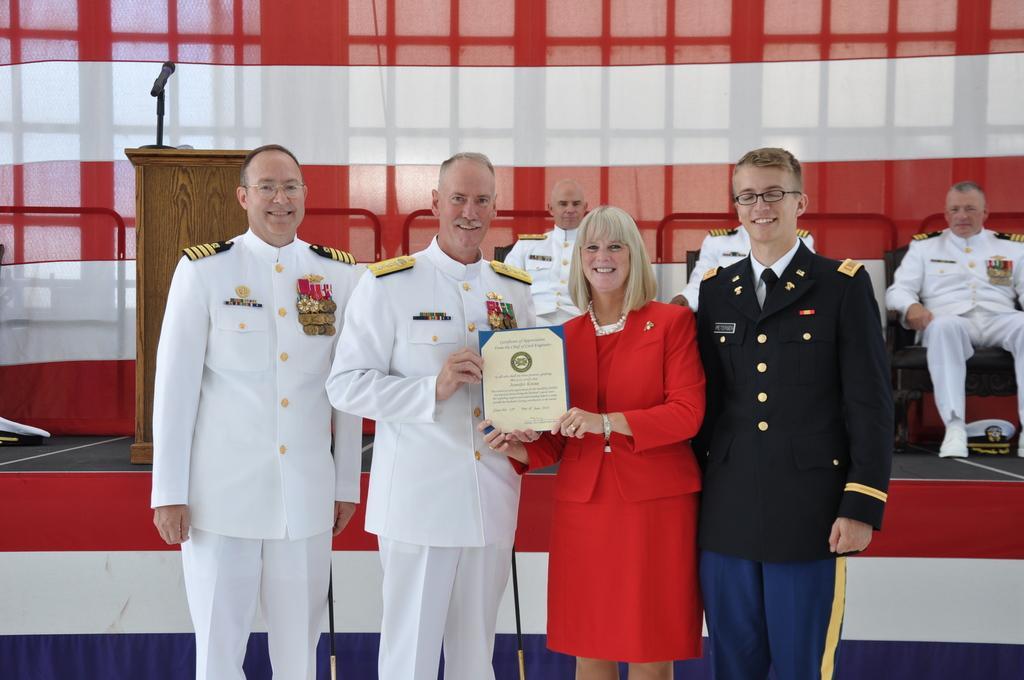Describe this image in one or two sentences. In this image I can see four persons standing. In front the person is wearing white color dress and holding the certificate. Background I can see two persons sitting and I can see the podium and a microphone and I can see the cloth in red and white color. 